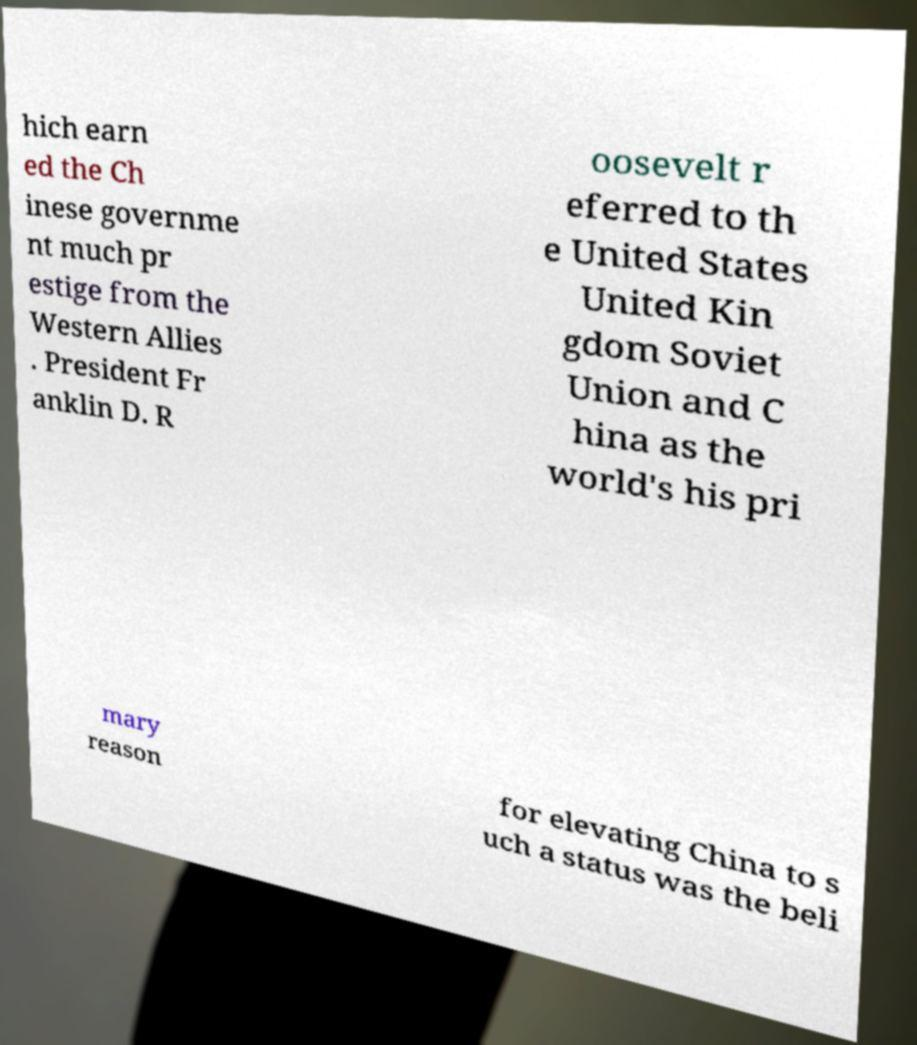Could you assist in decoding the text presented in this image and type it out clearly? hich earn ed the Ch inese governme nt much pr estige from the Western Allies . President Fr anklin D. R oosevelt r eferred to th e United States United Kin gdom Soviet Union and C hina as the world's his pri mary reason for elevating China to s uch a status was the beli 